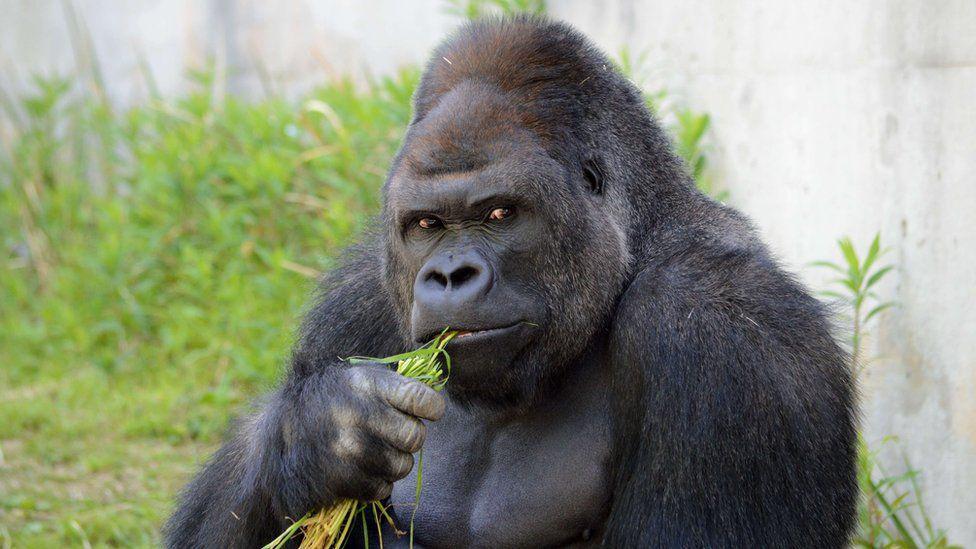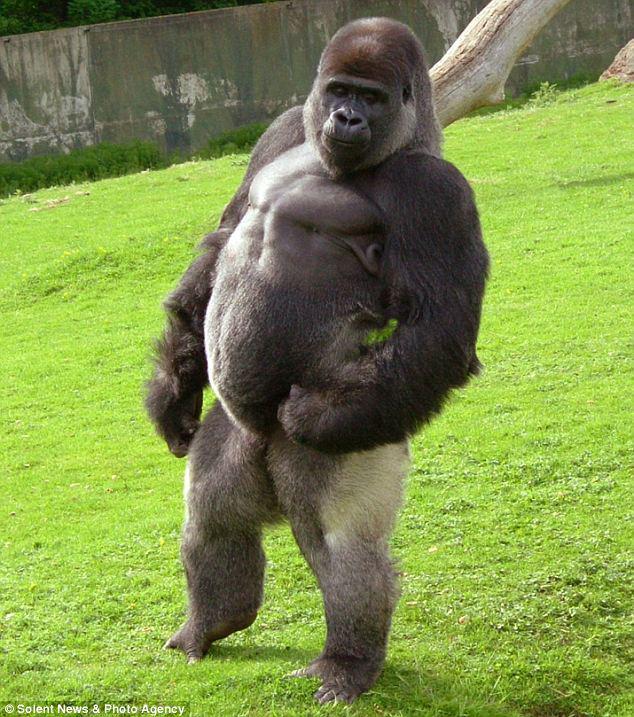The first image is the image on the left, the second image is the image on the right. Considering the images on both sides, is "The gorilla in the image on the right is standing completely upright." valid? Answer yes or no. Yes. The first image is the image on the left, the second image is the image on the right. For the images shown, is this caption "There is at least one monkey standing on all four paws." true? Answer yes or no. No. 